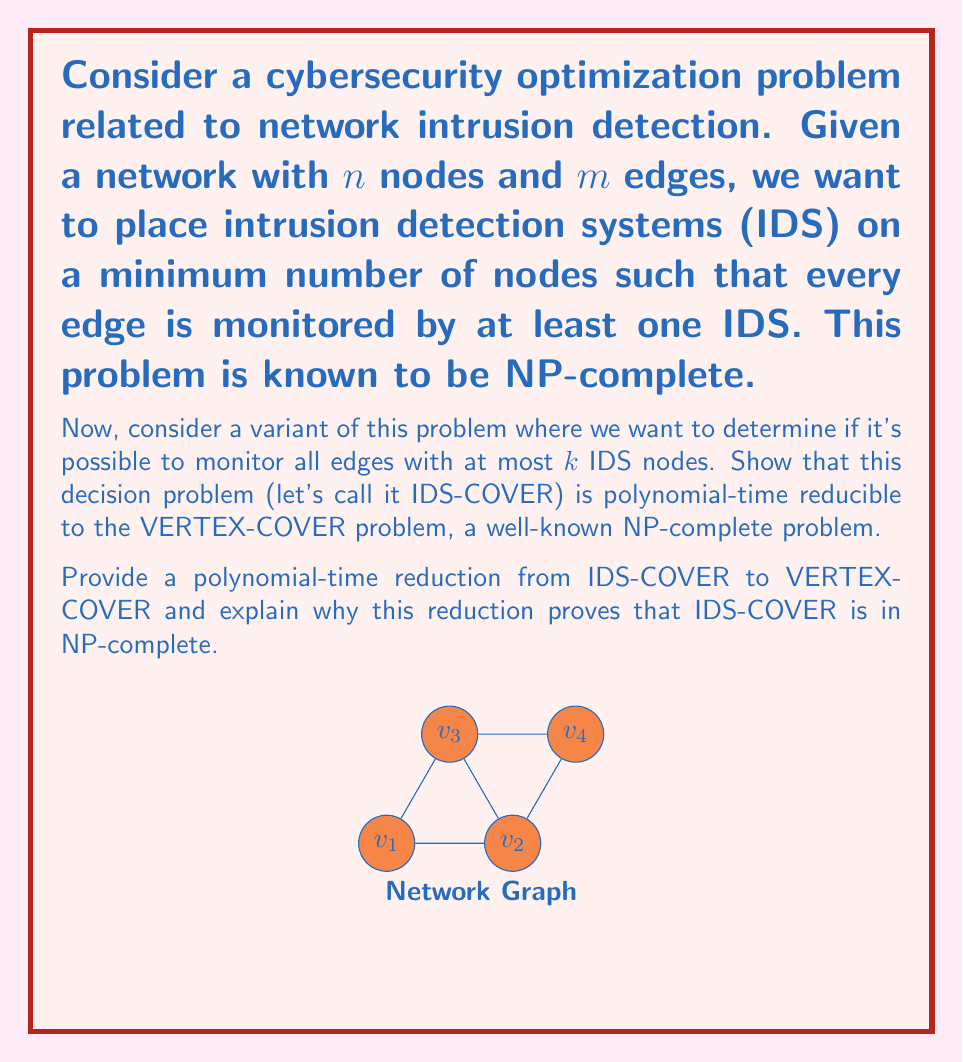Show me your answer to this math problem. To prove that IDS-COVER is polynomial-time reducible to VERTEX-COVER, we need to show a polynomial-time transformation from an instance of IDS-COVER to an instance of VERTEX-COVER. Here's the step-by-step reduction and explanation:

1. Reduction:
   - Given an instance of IDS-COVER with a graph $G = (V, E)$ and an integer $k$, create an instance of VERTEX-COVER with the same graph $G' = (V', E')$ where $V' = V$ and $E' = E$, and the same integer $k$.

2. Polynomial-time transformation:
   - This transformation is trivial and can be done in $O(1)$ time, as we're simply using the same graph and integer.

3. Correctness of the reduction:
   - We need to show that there exists a solution for IDS-COVER with at most $k$ IDS nodes if and only if there exists a vertex cover of size at most $k$ in $G'$.
   - If there's a solution to IDS-COVER with $k$ or fewer IDS nodes, these nodes form a vertex cover in $G'$ because every edge is monitored, which means at least one endpoint of each edge is an IDS node.
   - Conversely, if there's a vertex cover of size $k$ or less in $G'$, placing IDS on these nodes will monitor all edges in the original graph $G$.

4. NP-completeness proof:
   - VERTEX-COVER is known to be NP-complete.
   - We've shown a polynomial-time reduction from IDS-COVER to VERTEX-COVER.
   - This reduction proves that IDS-COVER is at least as hard as VERTEX-COVER.
   - To prove NP-completeness, we also need to show that IDS-COVER is in NP:
     - A solution to IDS-COVER can be verified in polynomial time by checking if the selected nodes cover all edges.
   - Therefore, IDS-COVER is in NP and is at least as hard as an NP-complete problem, making it NP-complete.

5. Implications for cybersecurity:
   - This reduction shows that optimal placement of intrusion detection systems is computationally hard.
   - In practice, approximation algorithms or heuristics may be needed for large-scale networks.
   - The connection to VERTEX-COVER allows leveraging existing algorithms and research for the IDS placement problem.
Answer: IDS-COVER $\leq_p$ VERTEX-COVER; both are NP-complete. 